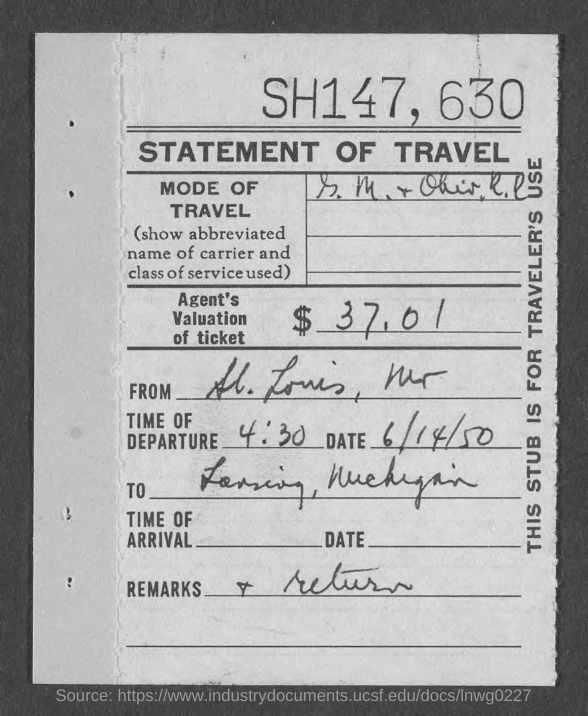Identify some key points in this picture. The document contains a reference to June 14, 1950. The amount is $37,01... The time of departure is 4:30. 